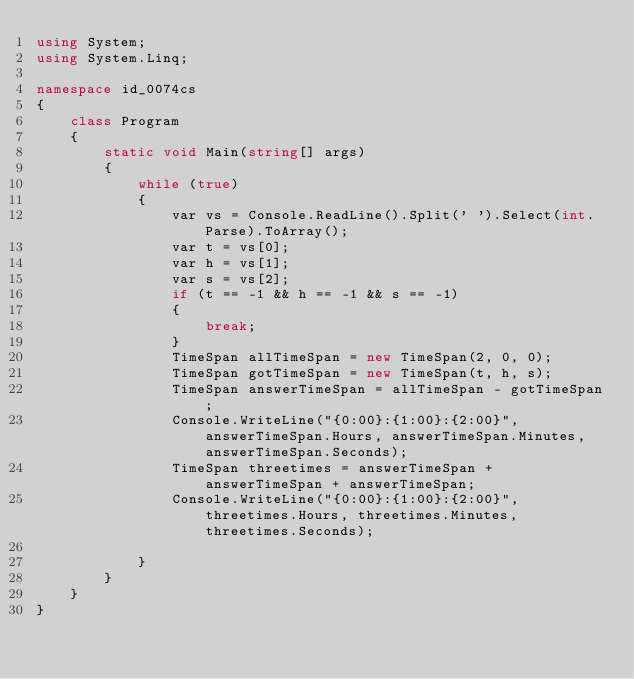Convert code to text. <code><loc_0><loc_0><loc_500><loc_500><_C#_>using System;
using System.Linq;

namespace id_0074cs
{
    class Program
    {
        static void Main(string[] args)
        {
            while (true)
            {
                var vs = Console.ReadLine().Split(' ').Select(int.Parse).ToArray();
                var t = vs[0];
                var h = vs[1];
                var s = vs[2];
                if (t == -1 && h == -1 && s == -1)
                {
                    break;
                }
                TimeSpan allTimeSpan = new TimeSpan(2, 0, 0);
                TimeSpan gotTimeSpan = new TimeSpan(t, h, s);
                TimeSpan answerTimeSpan = allTimeSpan - gotTimeSpan;
                Console.WriteLine("{0:00}:{1:00}:{2:00}", answerTimeSpan.Hours, answerTimeSpan.Minutes, answerTimeSpan.Seconds);
                TimeSpan threetimes = answerTimeSpan + answerTimeSpan + answerTimeSpan;
                Console.WriteLine("{0:00}:{1:00}:{2:00}", threetimes.Hours, threetimes.Minutes, threetimes.Seconds);

            }
        }
    }
}

</code> 